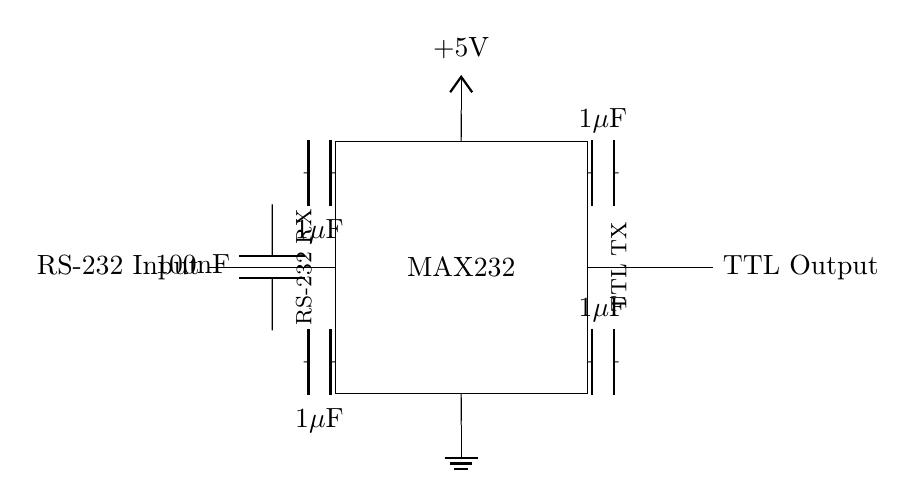¿Cuál es el componente principal de este circuito? El componente principal es el MAX232, que se identifica en el diagrama como un rectángulo donde se indica su nombre.
Answer: MAX232 ¿Qué tipo de capacitores se utilizan en este circuito? En el diagrama, se observa que se utilizan capacitores de un microfaradio, identificados con el símbolo 'C' y marcados como '1µF'.
Answer: 1 microfaradio ¿Cuál es la tensión de alimentación de este circuito? La tensión de alimentación está indicada en el circuito justo encima del MAX232, donde se muestra +5V.
Answer: 5 voltios ¿Cuántos capacitores hay en total en el circuito? Al contar los capacitores en el diagrama, hay cuatro capacitores: dos de un microfaradio y uno de cien nanofaradios.
Answer: Cuatro ¿Cómo se llama la salida del circuito? La salida del circuito se indica al final del diagrama, marcada como "TTL Output".
Answer: TTL Output ¿Qué función cumple el capacitor de cien nanofaradios en el circuito? El capacitor de cien nanofaradios se conecta a la entrada RS-232, generalmente se utiliza para filtrado o desacoplamiento, mejorando la calidad de la señal.
Answer: Filtrado ¿Cuáles son las entradas y salidas del circuito? La entrada del circuito es RS-232 RX y la salida es TTL TX, que se identifican en el diagrama.
Answer: RS-232 RX y TTL TX 